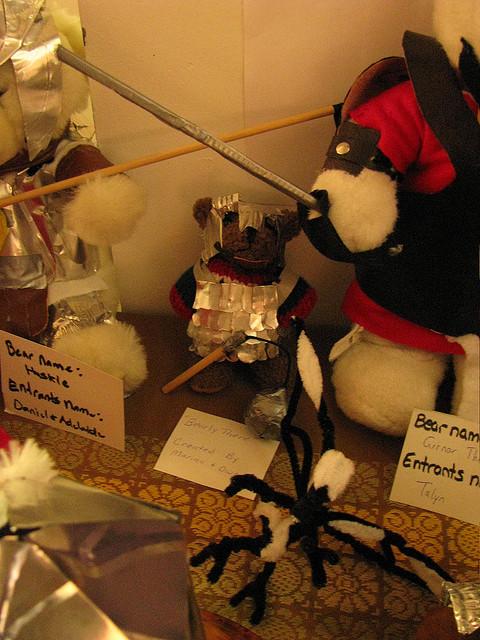What color is the wall?
Answer briefly. White. What are the round objects to the right?
Write a very short answer. Flowers. Is this in English?
Concise answer only. No. 